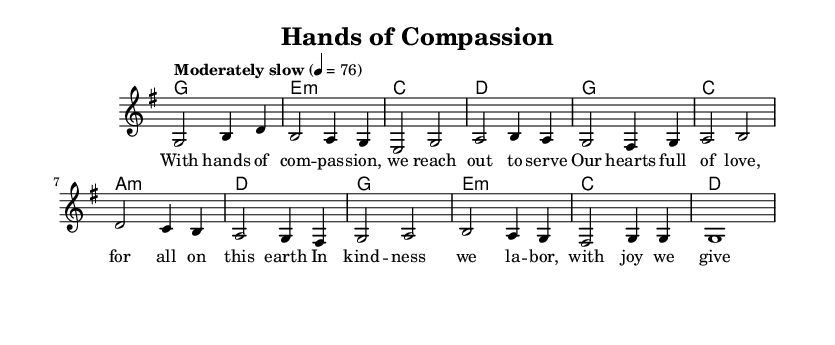What is the key signature of this music? The key signature is identified by the sharps or flats at the beginning of the staff. In this piece, there are no sharps or flats indicated, which corresponds to the key of G major.
Answer: G major What is the time signature of this piece? The time signature is indicated at the beginning of the music, showing how many beats are in each measure. In this score, the time signature is 4/4, meaning there are four beats per measure.
Answer: 4/4 What is the tempo marking for this piece? The tempo marking is given in the score, indicating how fast to play the piece. In this case, it states "Moderately slow" at a tempo of 76 beats per minute.
Answer: Moderately slow How many harmonies are there in the score? To determine the number of harmonies, we can review the chord changes listed after the melody. There are a total of three distinct harmonies repeated throughout the piece.
Answer: 3 What do the lyrics of the hymn express? The lyrics focus on themes of compassion and service, highlighting the importance of loving action towards others. Analyzing the text reveals a call to collaborate in building a better world.
Answer: Compassion and service What is the last note in the melody? To find the last note in the melody, we look at the final measure of the melody line. The last note is a whole note, indicated in the music as 'g', which concludes the musical phrase.
Answer: g 